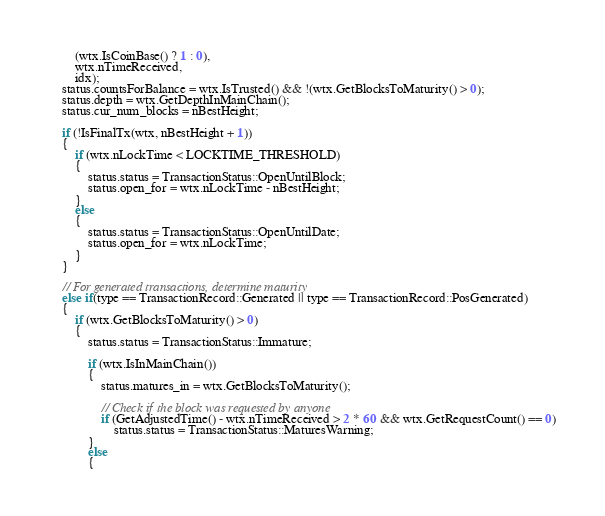<code> <loc_0><loc_0><loc_500><loc_500><_C++_>        (wtx.IsCoinBase() ? 1 : 0),
        wtx.nTimeReceived,
        idx);
    status.countsForBalance = wtx.IsTrusted() && !(wtx.GetBlocksToMaturity() > 0);
    status.depth = wtx.GetDepthInMainChain();
    status.cur_num_blocks = nBestHeight;

    if (!IsFinalTx(wtx, nBestHeight + 1))
    {
        if (wtx.nLockTime < LOCKTIME_THRESHOLD)
        {
            status.status = TransactionStatus::OpenUntilBlock;
            status.open_for = wtx.nLockTime - nBestHeight;
        }
        else
        {
            status.status = TransactionStatus::OpenUntilDate;
            status.open_for = wtx.nLockTime;
        }
    }

    // For generated transactions, determine maturity
    else if(type == TransactionRecord::Generated || type == TransactionRecord::PosGenerated)
    {
        if (wtx.GetBlocksToMaturity() > 0)
        {
            status.status = TransactionStatus::Immature;

            if (wtx.IsInMainChain())
            {
                status.matures_in = wtx.GetBlocksToMaturity();

                // Check if the block was requested by anyone
                if (GetAdjustedTime() - wtx.nTimeReceived > 2 * 60 && wtx.GetRequestCount() == 0)
                    status.status = TransactionStatus::MaturesWarning;
            }
            else
            {</code> 